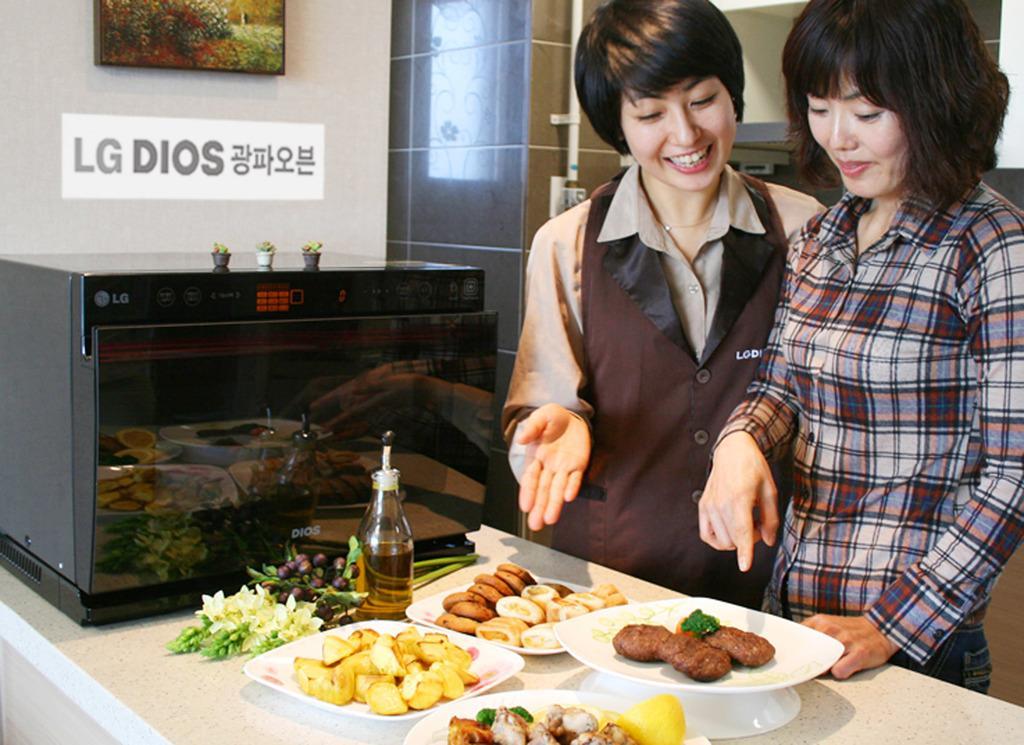How would you summarize this image in a sentence or two? On the right side of the image we can see two ladies standing, before them there is a table and we can see plates, oil, oven, flowers and some food placed on the table. In the background there is a wall and we can see wall frame placed on the wall. 